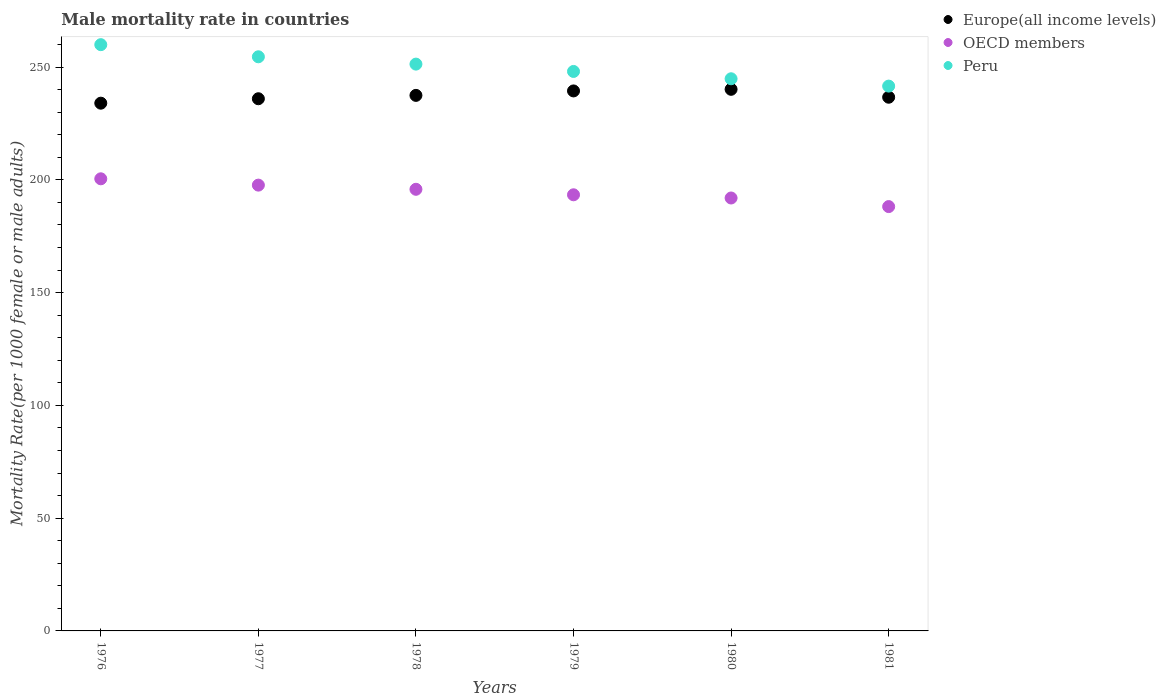How many different coloured dotlines are there?
Provide a succinct answer. 3. What is the male mortality rate in Europe(all income levels) in 1977?
Your response must be concise. 235.97. Across all years, what is the maximum male mortality rate in OECD members?
Make the answer very short. 200.47. Across all years, what is the minimum male mortality rate in Europe(all income levels)?
Offer a very short reply. 234. In which year was the male mortality rate in Peru maximum?
Keep it short and to the point. 1976. In which year was the male mortality rate in Europe(all income levels) minimum?
Make the answer very short. 1976. What is the total male mortality rate in Europe(all income levels) in the graph?
Your answer should be compact. 1423.67. What is the difference between the male mortality rate in OECD members in 1977 and that in 1980?
Offer a very short reply. 5.71. What is the difference between the male mortality rate in OECD members in 1981 and the male mortality rate in Peru in 1977?
Offer a very short reply. -66.42. What is the average male mortality rate in OECD members per year?
Give a very brief answer. 194.58. In the year 1981, what is the difference between the male mortality rate in Peru and male mortality rate in OECD members?
Provide a succinct answer. 53.42. In how many years, is the male mortality rate in Europe(all income levels) greater than 70?
Offer a terse response. 6. What is the ratio of the male mortality rate in OECD members in 1976 to that in 1981?
Make the answer very short. 1.07. Is the difference between the male mortality rate in Peru in 1979 and 1981 greater than the difference between the male mortality rate in OECD members in 1979 and 1981?
Give a very brief answer. Yes. What is the difference between the highest and the second highest male mortality rate in OECD members?
Provide a succinct answer. 2.81. What is the difference between the highest and the lowest male mortality rate in Peru?
Provide a short and direct response. 18.37. In how many years, is the male mortality rate in Europe(all income levels) greater than the average male mortality rate in Europe(all income levels) taken over all years?
Your response must be concise. 3. Is the male mortality rate in Europe(all income levels) strictly greater than the male mortality rate in OECD members over the years?
Offer a terse response. Yes. Is the male mortality rate in Europe(all income levels) strictly less than the male mortality rate in OECD members over the years?
Provide a succinct answer. No. How many dotlines are there?
Your answer should be very brief. 3. What is the difference between two consecutive major ticks on the Y-axis?
Ensure brevity in your answer.  50. Are the values on the major ticks of Y-axis written in scientific E-notation?
Ensure brevity in your answer.  No. Does the graph contain grids?
Make the answer very short. No. What is the title of the graph?
Your answer should be compact. Male mortality rate in countries. What is the label or title of the Y-axis?
Make the answer very short. Mortality Rate(per 1000 female or male adults). What is the Mortality Rate(per 1000 female or male adults) of Europe(all income levels) in 1976?
Provide a succinct answer. 234. What is the Mortality Rate(per 1000 female or male adults) of OECD members in 1976?
Your answer should be very brief. 200.47. What is the Mortality Rate(per 1000 female or male adults) of Peru in 1976?
Offer a very short reply. 259.95. What is the Mortality Rate(per 1000 female or male adults) of Europe(all income levels) in 1977?
Give a very brief answer. 235.97. What is the Mortality Rate(per 1000 female or male adults) in OECD members in 1977?
Ensure brevity in your answer.  197.67. What is the Mortality Rate(per 1000 female or male adults) of Peru in 1977?
Keep it short and to the point. 254.57. What is the Mortality Rate(per 1000 female or male adults) of Europe(all income levels) in 1978?
Your answer should be very brief. 237.46. What is the Mortality Rate(per 1000 female or male adults) of OECD members in 1978?
Provide a succinct answer. 195.82. What is the Mortality Rate(per 1000 female or male adults) of Peru in 1978?
Your response must be concise. 251.32. What is the Mortality Rate(per 1000 female or male adults) of Europe(all income levels) in 1979?
Offer a very short reply. 239.44. What is the Mortality Rate(per 1000 female or male adults) of OECD members in 1979?
Offer a terse response. 193.38. What is the Mortality Rate(per 1000 female or male adults) in Peru in 1979?
Provide a short and direct response. 248.07. What is the Mortality Rate(per 1000 female or male adults) of Europe(all income levels) in 1980?
Your answer should be compact. 240.15. What is the Mortality Rate(per 1000 female or male adults) in OECD members in 1980?
Ensure brevity in your answer.  191.96. What is the Mortality Rate(per 1000 female or male adults) in Peru in 1980?
Your answer should be very brief. 244.82. What is the Mortality Rate(per 1000 female or male adults) in Europe(all income levels) in 1981?
Provide a short and direct response. 236.64. What is the Mortality Rate(per 1000 female or male adults) of OECD members in 1981?
Offer a terse response. 188.15. What is the Mortality Rate(per 1000 female or male adults) in Peru in 1981?
Provide a succinct answer. 241.57. Across all years, what is the maximum Mortality Rate(per 1000 female or male adults) in Europe(all income levels)?
Make the answer very short. 240.15. Across all years, what is the maximum Mortality Rate(per 1000 female or male adults) in OECD members?
Give a very brief answer. 200.47. Across all years, what is the maximum Mortality Rate(per 1000 female or male adults) in Peru?
Offer a very short reply. 259.95. Across all years, what is the minimum Mortality Rate(per 1000 female or male adults) of Europe(all income levels)?
Keep it short and to the point. 234. Across all years, what is the minimum Mortality Rate(per 1000 female or male adults) in OECD members?
Your answer should be very brief. 188.15. Across all years, what is the minimum Mortality Rate(per 1000 female or male adults) of Peru?
Ensure brevity in your answer.  241.57. What is the total Mortality Rate(per 1000 female or male adults) of Europe(all income levels) in the graph?
Offer a very short reply. 1423.67. What is the total Mortality Rate(per 1000 female or male adults) of OECD members in the graph?
Ensure brevity in your answer.  1167.46. What is the total Mortality Rate(per 1000 female or male adults) of Peru in the graph?
Your response must be concise. 1500.32. What is the difference between the Mortality Rate(per 1000 female or male adults) of Europe(all income levels) in 1976 and that in 1977?
Provide a short and direct response. -1.97. What is the difference between the Mortality Rate(per 1000 female or male adults) of OECD members in 1976 and that in 1977?
Give a very brief answer. 2.81. What is the difference between the Mortality Rate(per 1000 female or male adults) of Peru in 1976 and that in 1977?
Make the answer very short. 5.37. What is the difference between the Mortality Rate(per 1000 female or male adults) in Europe(all income levels) in 1976 and that in 1978?
Provide a short and direct response. -3.46. What is the difference between the Mortality Rate(per 1000 female or male adults) of OECD members in 1976 and that in 1978?
Offer a very short reply. 4.65. What is the difference between the Mortality Rate(per 1000 female or male adults) of Peru in 1976 and that in 1978?
Keep it short and to the point. 8.62. What is the difference between the Mortality Rate(per 1000 female or male adults) of Europe(all income levels) in 1976 and that in 1979?
Provide a succinct answer. -5.44. What is the difference between the Mortality Rate(per 1000 female or male adults) of OECD members in 1976 and that in 1979?
Make the answer very short. 7.09. What is the difference between the Mortality Rate(per 1000 female or male adults) of Peru in 1976 and that in 1979?
Your answer should be very brief. 11.87. What is the difference between the Mortality Rate(per 1000 female or male adults) in Europe(all income levels) in 1976 and that in 1980?
Ensure brevity in your answer.  -6.15. What is the difference between the Mortality Rate(per 1000 female or male adults) of OECD members in 1976 and that in 1980?
Your answer should be compact. 8.51. What is the difference between the Mortality Rate(per 1000 female or male adults) of Peru in 1976 and that in 1980?
Your answer should be very brief. 15.12. What is the difference between the Mortality Rate(per 1000 female or male adults) of Europe(all income levels) in 1976 and that in 1981?
Ensure brevity in your answer.  -2.64. What is the difference between the Mortality Rate(per 1000 female or male adults) of OECD members in 1976 and that in 1981?
Ensure brevity in your answer.  12.32. What is the difference between the Mortality Rate(per 1000 female or male adults) in Peru in 1976 and that in 1981?
Keep it short and to the point. 18.37. What is the difference between the Mortality Rate(per 1000 female or male adults) of Europe(all income levels) in 1977 and that in 1978?
Your answer should be compact. -1.49. What is the difference between the Mortality Rate(per 1000 female or male adults) of OECD members in 1977 and that in 1978?
Offer a terse response. 1.85. What is the difference between the Mortality Rate(per 1000 female or male adults) in Europe(all income levels) in 1977 and that in 1979?
Ensure brevity in your answer.  -3.47. What is the difference between the Mortality Rate(per 1000 female or male adults) in OECD members in 1977 and that in 1979?
Give a very brief answer. 4.29. What is the difference between the Mortality Rate(per 1000 female or male adults) in Peru in 1977 and that in 1979?
Offer a terse response. 6.5. What is the difference between the Mortality Rate(per 1000 female or male adults) in Europe(all income levels) in 1977 and that in 1980?
Provide a short and direct response. -4.18. What is the difference between the Mortality Rate(per 1000 female or male adults) of OECD members in 1977 and that in 1980?
Offer a terse response. 5.71. What is the difference between the Mortality Rate(per 1000 female or male adults) of Peru in 1977 and that in 1980?
Ensure brevity in your answer.  9.75. What is the difference between the Mortality Rate(per 1000 female or male adults) of Europe(all income levels) in 1977 and that in 1981?
Your answer should be very brief. -0.67. What is the difference between the Mortality Rate(per 1000 female or male adults) of OECD members in 1977 and that in 1981?
Provide a succinct answer. 9.52. What is the difference between the Mortality Rate(per 1000 female or male adults) of Peru in 1977 and that in 1981?
Your answer should be compact. 13. What is the difference between the Mortality Rate(per 1000 female or male adults) in Europe(all income levels) in 1978 and that in 1979?
Provide a short and direct response. -1.98. What is the difference between the Mortality Rate(per 1000 female or male adults) in OECD members in 1978 and that in 1979?
Make the answer very short. 2.44. What is the difference between the Mortality Rate(per 1000 female or male adults) in Peru in 1978 and that in 1979?
Your response must be concise. 3.25. What is the difference between the Mortality Rate(per 1000 female or male adults) of Europe(all income levels) in 1978 and that in 1980?
Ensure brevity in your answer.  -2.69. What is the difference between the Mortality Rate(per 1000 female or male adults) in OECD members in 1978 and that in 1980?
Provide a short and direct response. 3.86. What is the difference between the Mortality Rate(per 1000 female or male adults) of Peru in 1978 and that in 1980?
Your response must be concise. 6.5. What is the difference between the Mortality Rate(per 1000 female or male adults) of Europe(all income levels) in 1978 and that in 1981?
Ensure brevity in your answer.  0.82. What is the difference between the Mortality Rate(per 1000 female or male adults) in OECD members in 1978 and that in 1981?
Your response must be concise. 7.67. What is the difference between the Mortality Rate(per 1000 female or male adults) of Peru in 1978 and that in 1981?
Provide a short and direct response. 9.75. What is the difference between the Mortality Rate(per 1000 female or male adults) of Europe(all income levels) in 1979 and that in 1980?
Offer a very short reply. -0.72. What is the difference between the Mortality Rate(per 1000 female or male adults) in OECD members in 1979 and that in 1980?
Ensure brevity in your answer.  1.42. What is the difference between the Mortality Rate(per 1000 female or male adults) in Europe(all income levels) in 1979 and that in 1981?
Give a very brief answer. 2.8. What is the difference between the Mortality Rate(per 1000 female or male adults) in OECD members in 1979 and that in 1981?
Provide a short and direct response. 5.23. What is the difference between the Mortality Rate(per 1000 female or male adults) of Peru in 1979 and that in 1981?
Your answer should be very brief. 6.5. What is the difference between the Mortality Rate(per 1000 female or male adults) in Europe(all income levels) in 1980 and that in 1981?
Your answer should be compact. 3.51. What is the difference between the Mortality Rate(per 1000 female or male adults) of OECD members in 1980 and that in 1981?
Your answer should be very brief. 3.81. What is the difference between the Mortality Rate(per 1000 female or male adults) of Peru in 1980 and that in 1981?
Make the answer very short. 3.25. What is the difference between the Mortality Rate(per 1000 female or male adults) of Europe(all income levels) in 1976 and the Mortality Rate(per 1000 female or male adults) of OECD members in 1977?
Give a very brief answer. 36.33. What is the difference between the Mortality Rate(per 1000 female or male adults) in Europe(all income levels) in 1976 and the Mortality Rate(per 1000 female or male adults) in Peru in 1977?
Provide a short and direct response. -20.57. What is the difference between the Mortality Rate(per 1000 female or male adults) in OECD members in 1976 and the Mortality Rate(per 1000 female or male adults) in Peru in 1977?
Provide a succinct answer. -54.1. What is the difference between the Mortality Rate(per 1000 female or male adults) of Europe(all income levels) in 1976 and the Mortality Rate(per 1000 female or male adults) of OECD members in 1978?
Your answer should be very brief. 38.18. What is the difference between the Mortality Rate(per 1000 female or male adults) in Europe(all income levels) in 1976 and the Mortality Rate(per 1000 female or male adults) in Peru in 1978?
Keep it short and to the point. -17.32. What is the difference between the Mortality Rate(per 1000 female or male adults) of OECD members in 1976 and the Mortality Rate(per 1000 female or male adults) of Peru in 1978?
Offer a very short reply. -50.85. What is the difference between the Mortality Rate(per 1000 female or male adults) of Europe(all income levels) in 1976 and the Mortality Rate(per 1000 female or male adults) of OECD members in 1979?
Provide a short and direct response. 40.62. What is the difference between the Mortality Rate(per 1000 female or male adults) of Europe(all income levels) in 1976 and the Mortality Rate(per 1000 female or male adults) of Peru in 1979?
Ensure brevity in your answer.  -14.07. What is the difference between the Mortality Rate(per 1000 female or male adults) in OECD members in 1976 and the Mortality Rate(per 1000 female or male adults) in Peru in 1979?
Keep it short and to the point. -47.6. What is the difference between the Mortality Rate(per 1000 female or male adults) of Europe(all income levels) in 1976 and the Mortality Rate(per 1000 female or male adults) of OECD members in 1980?
Provide a succinct answer. 42.04. What is the difference between the Mortality Rate(per 1000 female or male adults) of Europe(all income levels) in 1976 and the Mortality Rate(per 1000 female or male adults) of Peru in 1980?
Ensure brevity in your answer.  -10.82. What is the difference between the Mortality Rate(per 1000 female or male adults) in OECD members in 1976 and the Mortality Rate(per 1000 female or male adults) in Peru in 1980?
Ensure brevity in your answer.  -44.35. What is the difference between the Mortality Rate(per 1000 female or male adults) of Europe(all income levels) in 1976 and the Mortality Rate(per 1000 female or male adults) of OECD members in 1981?
Ensure brevity in your answer.  45.85. What is the difference between the Mortality Rate(per 1000 female or male adults) in Europe(all income levels) in 1976 and the Mortality Rate(per 1000 female or male adults) in Peru in 1981?
Make the answer very short. -7.57. What is the difference between the Mortality Rate(per 1000 female or male adults) of OECD members in 1976 and the Mortality Rate(per 1000 female or male adults) of Peru in 1981?
Provide a short and direct response. -41.1. What is the difference between the Mortality Rate(per 1000 female or male adults) of Europe(all income levels) in 1977 and the Mortality Rate(per 1000 female or male adults) of OECD members in 1978?
Provide a short and direct response. 40.15. What is the difference between the Mortality Rate(per 1000 female or male adults) of Europe(all income levels) in 1977 and the Mortality Rate(per 1000 female or male adults) of Peru in 1978?
Your answer should be compact. -15.35. What is the difference between the Mortality Rate(per 1000 female or male adults) of OECD members in 1977 and the Mortality Rate(per 1000 female or male adults) of Peru in 1978?
Offer a terse response. -53.66. What is the difference between the Mortality Rate(per 1000 female or male adults) of Europe(all income levels) in 1977 and the Mortality Rate(per 1000 female or male adults) of OECD members in 1979?
Provide a succinct answer. 42.59. What is the difference between the Mortality Rate(per 1000 female or male adults) in Europe(all income levels) in 1977 and the Mortality Rate(per 1000 female or male adults) in Peru in 1979?
Provide a succinct answer. -12.1. What is the difference between the Mortality Rate(per 1000 female or male adults) of OECD members in 1977 and the Mortality Rate(per 1000 female or male adults) of Peru in 1979?
Offer a terse response. -50.4. What is the difference between the Mortality Rate(per 1000 female or male adults) in Europe(all income levels) in 1977 and the Mortality Rate(per 1000 female or male adults) in OECD members in 1980?
Give a very brief answer. 44.01. What is the difference between the Mortality Rate(per 1000 female or male adults) in Europe(all income levels) in 1977 and the Mortality Rate(per 1000 female or male adults) in Peru in 1980?
Keep it short and to the point. -8.85. What is the difference between the Mortality Rate(per 1000 female or male adults) of OECD members in 1977 and the Mortality Rate(per 1000 female or male adults) of Peru in 1980?
Offer a terse response. -47.15. What is the difference between the Mortality Rate(per 1000 female or male adults) of Europe(all income levels) in 1977 and the Mortality Rate(per 1000 female or male adults) of OECD members in 1981?
Your response must be concise. 47.82. What is the difference between the Mortality Rate(per 1000 female or male adults) in Europe(all income levels) in 1977 and the Mortality Rate(per 1000 female or male adults) in Peru in 1981?
Ensure brevity in your answer.  -5.6. What is the difference between the Mortality Rate(per 1000 female or male adults) of OECD members in 1977 and the Mortality Rate(per 1000 female or male adults) of Peru in 1981?
Your response must be concise. -43.9. What is the difference between the Mortality Rate(per 1000 female or male adults) in Europe(all income levels) in 1978 and the Mortality Rate(per 1000 female or male adults) in OECD members in 1979?
Your response must be concise. 44.08. What is the difference between the Mortality Rate(per 1000 female or male adults) in Europe(all income levels) in 1978 and the Mortality Rate(per 1000 female or male adults) in Peru in 1979?
Offer a terse response. -10.61. What is the difference between the Mortality Rate(per 1000 female or male adults) of OECD members in 1978 and the Mortality Rate(per 1000 female or male adults) of Peru in 1979?
Your answer should be compact. -52.25. What is the difference between the Mortality Rate(per 1000 female or male adults) of Europe(all income levels) in 1978 and the Mortality Rate(per 1000 female or male adults) of OECD members in 1980?
Ensure brevity in your answer.  45.5. What is the difference between the Mortality Rate(per 1000 female or male adults) of Europe(all income levels) in 1978 and the Mortality Rate(per 1000 female or male adults) of Peru in 1980?
Offer a very short reply. -7.36. What is the difference between the Mortality Rate(per 1000 female or male adults) in OECD members in 1978 and the Mortality Rate(per 1000 female or male adults) in Peru in 1980?
Your answer should be compact. -49. What is the difference between the Mortality Rate(per 1000 female or male adults) in Europe(all income levels) in 1978 and the Mortality Rate(per 1000 female or male adults) in OECD members in 1981?
Keep it short and to the point. 49.31. What is the difference between the Mortality Rate(per 1000 female or male adults) in Europe(all income levels) in 1978 and the Mortality Rate(per 1000 female or male adults) in Peru in 1981?
Ensure brevity in your answer.  -4.11. What is the difference between the Mortality Rate(per 1000 female or male adults) in OECD members in 1978 and the Mortality Rate(per 1000 female or male adults) in Peru in 1981?
Offer a terse response. -45.75. What is the difference between the Mortality Rate(per 1000 female or male adults) of Europe(all income levels) in 1979 and the Mortality Rate(per 1000 female or male adults) of OECD members in 1980?
Keep it short and to the point. 47.48. What is the difference between the Mortality Rate(per 1000 female or male adults) in Europe(all income levels) in 1979 and the Mortality Rate(per 1000 female or male adults) in Peru in 1980?
Ensure brevity in your answer.  -5.39. What is the difference between the Mortality Rate(per 1000 female or male adults) in OECD members in 1979 and the Mortality Rate(per 1000 female or male adults) in Peru in 1980?
Provide a succinct answer. -51.44. What is the difference between the Mortality Rate(per 1000 female or male adults) of Europe(all income levels) in 1979 and the Mortality Rate(per 1000 female or male adults) of OECD members in 1981?
Your answer should be very brief. 51.29. What is the difference between the Mortality Rate(per 1000 female or male adults) in Europe(all income levels) in 1979 and the Mortality Rate(per 1000 female or male adults) in Peru in 1981?
Give a very brief answer. -2.13. What is the difference between the Mortality Rate(per 1000 female or male adults) in OECD members in 1979 and the Mortality Rate(per 1000 female or male adults) in Peru in 1981?
Your answer should be very brief. -48.19. What is the difference between the Mortality Rate(per 1000 female or male adults) in Europe(all income levels) in 1980 and the Mortality Rate(per 1000 female or male adults) in OECD members in 1981?
Provide a succinct answer. 52. What is the difference between the Mortality Rate(per 1000 female or male adults) in Europe(all income levels) in 1980 and the Mortality Rate(per 1000 female or male adults) in Peru in 1981?
Ensure brevity in your answer.  -1.42. What is the difference between the Mortality Rate(per 1000 female or male adults) of OECD members in 1980 and the Mortality Rate(per 1000 female or male adults) of Peru in 1981?
Provide a succinct answer. -49.61. What is the average Mortality Rate(per 1000 female or male adults) of Europe(all income levels) per year?
Your answer should be compact. 237.28. What is the average Mortality Rate(per 1000 female or male adults) in OECD members per year?
Make the answer very short. 194.58. What is the average Mortality Rate(per 1000 female or male adults) of Peru per year?
Make the answer very short. 250.05. In the year 1976, what is the difference between the Mortality Rate(per 1000 female or male adults) of Europe(all income levels) and Mortality Rate(per 1000 female or male adults) of OECD members?
Your response must be concise. 33.53. In the year 1976, what is the difference between the Mortality Rate(per 1000 female or male adults) of Europe(all income levels) and Mortality Rate(per 1000 female or male adults) of Peru?
Ensure brevity in your answer.  -25.94. In the year 1976, what is the difference between the Mortality Rate(per 1000 female or male adults) of OECD members and Mortality Rate(per 1000 female or male adults) of Peru?
Make the answer very short. -59.47. In the year 1977, what is the difference between the Mortality Rate(per 1000 female or male adults) of Europe(all income levels) and Mortality Rate(per 1000 female or male adults) of OECD members?
Provide a succinct answer. 38.3. In the year 1977, what is the difference between the Mortality Rate(per 1000 female or male adults) in Europe(all income levels) and Mortality Rate(per 1000 female or male adults) in Peru?
Your response must be concise. -18.6. In the year 1977, what is the difference between the Mortality Rate(per 1000 female or male adults) in OECD members and Mortality Rate(per 1000 female or male adults) in Peru?
Provide a short and direct response. -56.91. In the year 1978, what is the difference between the Mortality Rate(per 1000 female or male adults) of Europe(all income levels) and Mortality Rate(per 1000 female or male adults) of OECD members?
Give a very brief answer. 41.64. In the year 1978, what is the difference between the Mortality Rate(per 1000 female or male adults) of Europe(all income levels) and Mortality Rate(per 1000 female or male adults) of Peru?
Give a very brief answer. -13.86. In the year 1978, what is the difference between the Mortality Rate(per 1000 female or male adults) of OECD members and Mortality Rate(per 1000 female or male adults) of Peru?
Ensure brevity in your answer.  -55.5. In the year 1979, what is the difference between the Mortality Rate(per 1000 female or male adults) in Europe(all income levels) and Mortality Rate(per 1000 female or male adults) in OECD members?
Your answer should be very brief. 46.06. In the year 1979, what is the difference between the Mortality Rate(per 1000 female or male adults) in Europe(all income levels) and Mortality Rate(per 1000 female or male adults) in Peru?
Provide a short and direct response. -8.64. In the year 1979, what is the difference between the Mortality Rate(per 1000 female or male adults) of OECD members and Mortality Rate(per 1000 female or male adults) of Peru?
Make the answer very short. -54.69. In the year 1980, what is the difference between the Mortality Rate(per 1000 female or male adults) of Europe(all income levels) and Mortality Rate(per 1000 female or male adults) of OECD members?
Ensure brevity in your answer.  48.19. In the year 1980, what is the difference between the Mortality Rate(per 1000 female or male adults) in Europe(all income levels) and Mortality Rate(per 1000 female or male adults) in Peru?
Ensure brevity in your answer.  -4.67. In the year 1980, what is the difference between the Mortality Rate(per 1000 female or male adults) in OECD members and Mortality Rate(per 1000 female or male adults) in Peru?
Make the answer very short. -52.86. In the year 1981, what is the difference between the Mortality Rate(per 1000 female or male adults) in Europe(all income levels) and Mortality Rate(per 1000 female or male adults) in OECD members?
Your response must be concise. 48.49. In the year 1981, what is the difference between the Mortality Rate(per 1000 female or male adults) in Europe(all income levels) and Mortality Rate(per 1000 female or male adults) in Peru?
Provide a succinct answer. -4.93. In the year 1981, what is the difference between the Mortality Rate(per 1000 female or male adults) in OECD members and Mortality Rate(per 1000 female or male adults) in Peru?
Your response must be concise. -53.42. What is the ratio of the Mortality Rate(per 1000 female or male adults) of Europe(all income levels) in 1976 to that in 1977?
Your answer should be compact. 0.99. What is the ratio of the Mortality Rate(per 1000 female or male adults) of OECD members in 1976 to that in 1977?
Ensure brevity in your answer.  1.01. What is the ratio of the Mortality Rate(per 1000 female or male adults) in Peru in 1976 to that in 1977?
Ensure brevity in your answer.  1.02. What is the ratio of the Mortality Rate(per 1000 female or male adults) of Europe(all income levels) in 1976 to that in 1978?
Keep it short and to the point. 0.99. What is the ratio of the Mortality Rate(per 1000 female or male adults) of OECD members in 1976 to that in 1978?
Your answer should be compact. 1.02. What is the ratio of the Mortality Rate(per 1000 female or male adults) of Peru in 1976 to that in 1978?
Make the answer very short. 1.03. What is the ratio of the Mortality Rate(per 1000 female or male adults) of Europe(all income levels) in 1976 to that in 1979?
Your answer should be very brief. 0.98. What is the ratio of the Mortality Rate(per 1000 female or male adults) of OECD members in 1976 to that in 1979?
Make the answer very short. 1.04. What is the ratio of the Mortality Rate(per 1000 female or male adults) of Peru in 1976 to that in 1979?
Your answer should be compact. 1.05. What is the ratio of the Mortality Rate(per 1000 female or male adults) of Europe(all income levels) in 1976 to that in 1980?
Your answer should be compact. 0.97. What is the ratio of the Mortality Rate(per 1000 female or male adults) in OECD members in 1976 to that in 1980?
Your response must be concise. 1.04. What is the ratio of the Mortality Rate(per 1000 female or male adults) of Peru in 1976 to that in 1980?
Offer a terse response. 1.06. What is the ratio of the Mortality Rate(per 1000 female or male adults) in Europe(all income levels) in 1976 to that in 1981?
Give a very brief answer. 0.99. What is the ratio of the Mortality Rate(per 1000 female or male adults) in OECD members in 1976 to that in 1981?
Offer a terse response. 1.07. What is the ratio of the Mortality Rate(per 1000 female or male adults) in Peru in 1976 to that in 1981?
Offer a very short reply. 1.08. What is the ratio of the Mortality Rate(per 1000 female or male adults) in Europe(all income levels) in 1977 to that in 1978?
Keep it short and to the point. 0.99. What is the ratio of the Mortality Rate(per 1000 female or male adults) of OECD members in 1977 to that in 1978?
Give a very brief answer. 1.01. What is the ratio of the Mortality Rate(per 1000 female or male adults) of Peru in 1977 to that in 1978?
Your response must be concise. 1.01. What is the ratio of the Mortality Rate(per 1000 female or male adults) of Europe(all income levels) in 1977 to that in 1979?
Your answer should be compact. 0.99. What is the ratio of the Mortality Rate(per 1000 female or male adults) of OECD members in 1977 to that in 1979?
Provide a succinct answer. 1.02. What is the ratio of the Mortality Rate(per 1000 female or male adults) of Peru in 1977 to that in 1979?
Your answer should be compact. 1.03. What is the ratio of the Mortality Rate(per 1000 female or male adults) in Europe(all income levels) in 1977 to that in 1980?
Give a very brief answer. 0.98. What is the ratio of the Mortality Rate(per 1000 female or male adults) in OECD members in 1977 to that in 1980?
Offer a terse response. 1.03. What is the ratio of the Mortality Rate(per 1000 female or male adults) in Peru in 1977 to that in 1980?
Provide a succinct answer. 1.04. What is the ratio of the Mortality Rate(per 1000 female or male adults) in OECD members in 1977 to that in 1981?
Make the answer very short. 1.05. What is the ratio of the Mortality Rate(per 1000 female or male adults) in Peru in 1977 to that in 1981?
Give a very brief answer. 1.05. What is the ratio of the Mortality Rate(per 1000 female or male adults) of Europe(all income levels) in 1978 to that in 1979?
Make the answer very short. 0.99. What is the ratio of the Mortality Rate(per 1000 female or male adults) of OECD members in 1978 to that in 1979?
Ensure brevity in your answer.  1.01. What is the ratio of the Mortality Rate(per 1000 female or male adults) in Peru in 1978 to that in 1979?
Your response must be concise. 1.01. What is the ratio of the Mortality Rate(per 1000 female or male adults) of Europe(all income levels) in 1978 to that in 1980?
Ensure brevity in your answer.  0.99. What is the ratio of the Mortality Rate(per 1000 female or male adults) in OECD members in 1978 to that in 1980?
Ensure brevity in your answer.  1.02. What is the ratio of the Mortality Rate(per 1000 female or male adults) of Peru in 1978 to that in 1980?
Make the answer very short. 1.03. What is the ratio of the Mortality Rate(per 1000 female or male adults) in OECD members in 1978 to that in 1981?
Make the answer very short. 1.04. What is the ratio of the Mortality Rate(per 1000 female or male adults) of Peru in 1978 to that in 1981?
Ensure brevity in your answer.  1.04. What is the ratio of the Mortality Rate(per 1000 female or male adults) in Europe(all income levels) in 1979 to that in 1980?
Your response must be concise. 1. What is the ratio of the Mortality Rate(per 1000 female or male adults) of OECD members in 1979 to that in 1980?
Your answer should be very brief. 1.01. What is the ratio of the Mortality Rate(per 1000 female or male adults) of Peru in 1979 to that in 1980?
Offer a terse response. 1.01. What is the ratio of the Mortality Rate(per 1000 female or male adults) of Europe(all income levels) in 1979 to that in 1981?
Give a very brief answer. 1.01. What is the ratio of the Mortality Rate(per 1000 female or male adults) in OECD members in 1979 to that in 1981?
Ensure brevity in your answer.  1.03. What is the ratio of the Mortality Rate(per 1000 female or male adults) of Peru in 1979 to that in 1981?
Your answer should be very brief. 1.03. What is the ratio of the Mortality Rate(per 1000 female or male adults) of Europe(all income levels) in 1980 to that in 1981?
Your answer should be very brief. 1.01. What is the ratio of the Mortality Rate(per 1000 female or male adults) of OECD members in 1980 to that in 1981?
Provide a succinct answer. 1.02. What is the ratio of the Mortality Rate(per 1000 female or male adults) in Peru in 1980 to that in 1981?
Offer a very short reply. 1.01. What is the difference between the highest and the second highest Mortality Rate(per 1000 female or male adults) of Europe(all income levels)?
Provide a short and direct response. 0.72. What is the difference between the highest and the second highest Mortality Rate(per 1000 female or male adults) in OECD members?
Give a very brief answer. 2.81. What is the difference between the highest and the second highest Mortality Rate(per 1000 female or male adults) of Peru?
Provide a succinct answer. 5.37. What is the difference between the highest and the lowest Mortality Rate(per 1000 female or male adults) in Europe(all income levels)?
Give a very brief answer. 6.15. What is the difference between the highest and the lowest Mortality Rate(per 1000 female or male adults) in OECD members?
Give a very brief answer. 12.32. What is the difference between the highest and the lowest Mortality Rate(per 1000 female or male adults) of Peru?
Offer a terse response. 18.37. 